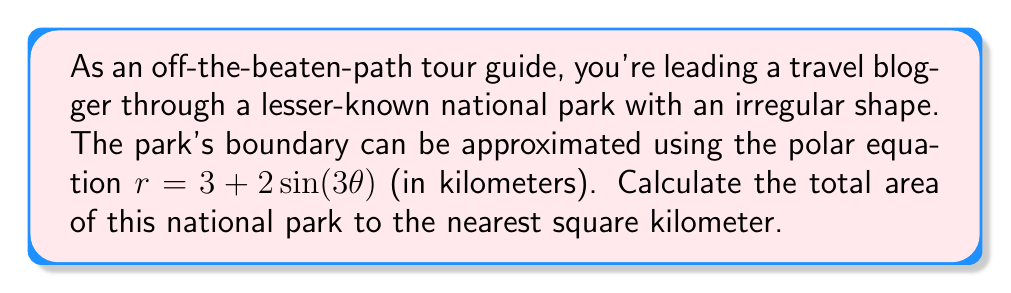Can you answer this question? To calculate the area of this irregularly shaped national park, we'll use the formula for the area of a polar region:

$$ A = \frac{1}{2} \int_{0}^{2\pi} r^2(\theta) \, d\theta $$

Where $r(\theta) = 3 + 2\sin(3\theta)$

Steps:
1) Substitute the given equation into the area formula:

$$ A = \frac{1}{2} \int_{0}^{2\pi} (3 + 2\sin(3\theta))^2 \, d\theta $$

2) Expand the squared term:

$$ A = \frac{1}{2} \int_{0}^{2\pi} (9 + 12\sin(3\theta) + 4\sin^2(3\theta)) \, d\theta $$

3) Integrate each term:

   a) $\int_{0}^{2\pi} 9 \, d\theta = 9\theta \big|_{0}^{2\pi} = 18\pi$
   
   b) $\int_{0}^{2\pi} 12\sin(3\theta) \, d\theta = -4\cos(3\theta) \big|_{0}^{2\pi} = 0$
   
   c) $\int_{0}^{2\pi} 4\sin^2(3\theta) \, d\theta = 2\theta - \frac{2}{3}\sin(6\theta) \big|_{0}^{2\pi} = 4\pi$

4) Sum the results:

$$ A = \frac{1}{2} (18\pi + 0 + 4\pi) = 11\pi $$

5) Convert to square kilometers:

$$ A = 11\pi \approx 34.56 \text{ km}^2 $$

6) Round to the nearest square kilometer:

$$ A \approx 35 \text{ km}^2 $$
Answer: 35 km² 